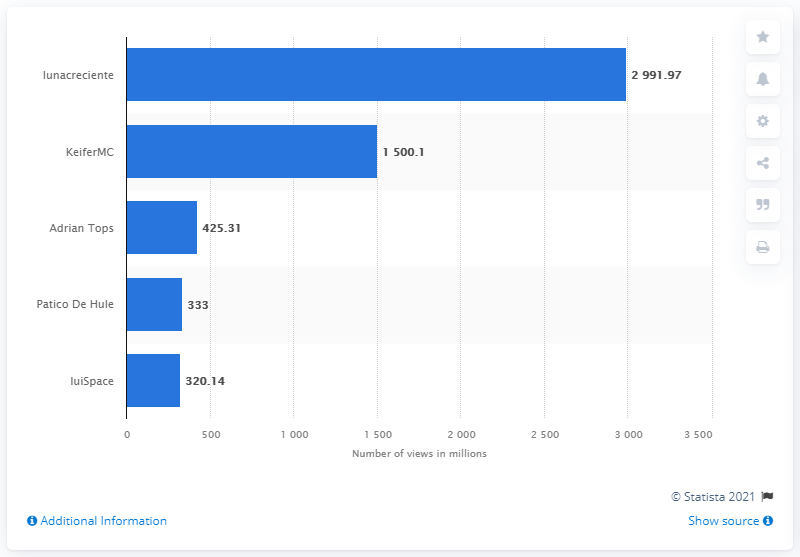Give some essential details in this illustration. In March 2021, KeiferMC was the second most viewed YouTube channel in Venezuela. The most viewed YouTube channel in Venezuela as of March 2021 was Lunacreciente. 